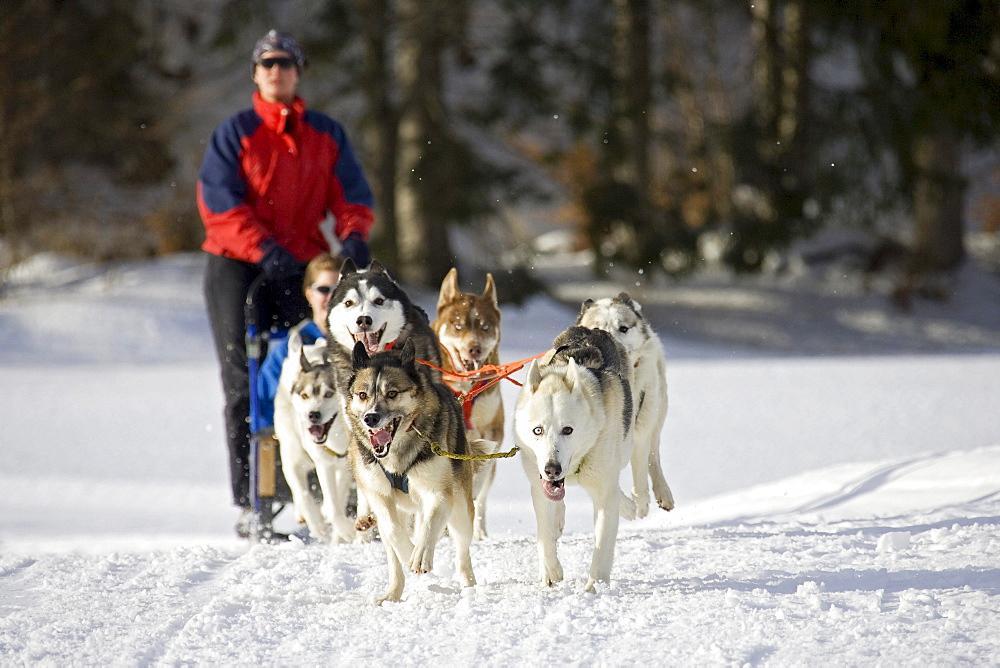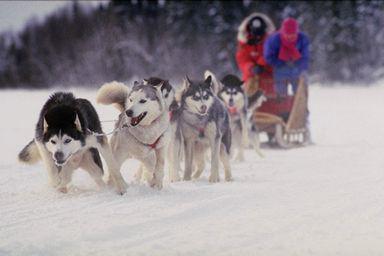The first image is the image on the left, the second image is the image on the right. For the images displayed, is the sentence "One image in the pair shows multiple dog sleds and the other shows a single dog sled with multiple people riding." factually correct? Answer yes or no. No. The first image is the image on the left, the second image is the image on the right. Assess this claim about the two images: "At least two dogs are in the foreground leading a dog sled in each image, and each image shows a dog team heading toward the camera.". Correct or not? Answer yes or no. Yes. 